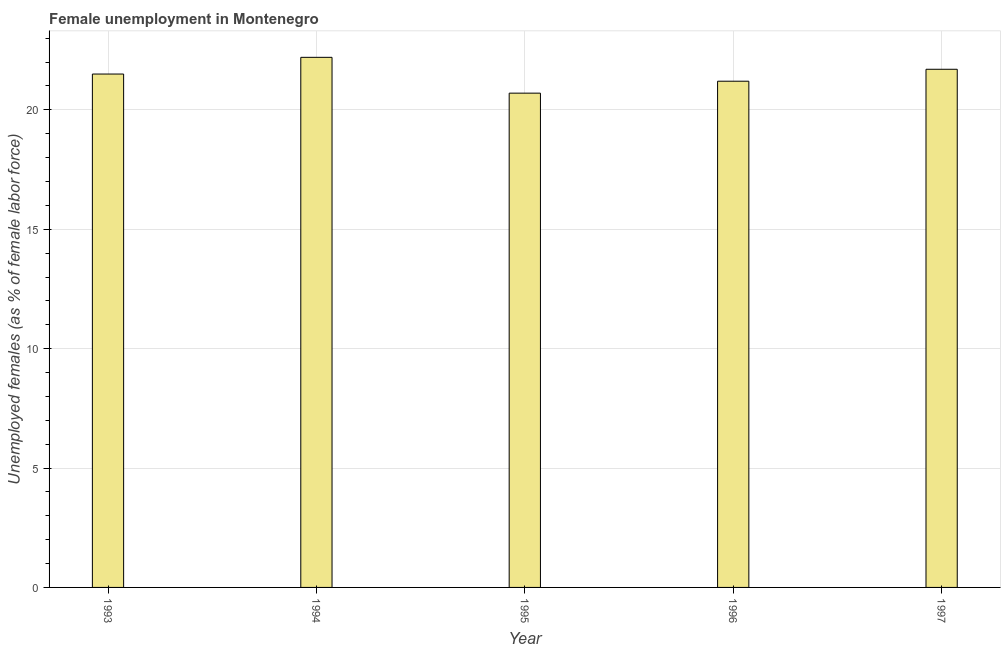Does the graph contain any zero values?
Keep it short and to the point. No. What is the title of the graph?
Provide a short and direct response. Female unemployment in Montenegro. What is the label or title of the Y-axis?
Ensure brevity in your answer.  Unemployed females (as % of female labor force). Across all years, what is the maximum unemployed females population?
Give a very brief answer. 22.2. Across all years, what is the minimum unemployed females population?
Ensure brevity in your answer.  20.7. In which year was the unemployed females population maximum?
Your answer should be very brief. 1994. In which year was the unemployed females population minimum?
Your answer should be very brief. 1995. What is the sum of the unemployed females population?
Make the answer very short. 107.3. What is the difference between the unemployed females population in 1993 and 1994?
Offer a very short reply. -0.7. What is the average unemployed females population per year?
Your answer should be compact. 21.46. In how many years, is the unemployed females population greater than 12 %?
Ensure brevity in your answer.  5. Do a majority of the years between 1994 and 1997 (inclusive) have unemployed females population greater than 1 %?
Provide a succinct answer. Yes. Is the sum of the unemployed females population in 1994 and 1997 greater than the maximum unemployed females population across all years?
Your answer should be compact. Yes. What is the difference between the highest and the lowest unemployed females population?
Ensure brevity in your answer.  1.5. In how many years, is the unemployed females population greater than the average unemployed females population taken over all years?
Make the answer very short. 3. How many bars are there?
Your response must be concise. 5. Are all the bars in the graph horizontal?
Your answer should be compact. No. How many years are there in the graph?
Provide a short and direct response. 5. What is the difference between two consecutive major ticks on the Y-axis?
Provide a short and direct response. 5. Are the values on the major ticks of Y-axis written in scientific E-notation?
Provide a short and direct response. No. What is the Unemployed females (as % of female labor force) in 1994?
Keep it short and to the point. 22.2. What is the Unemployed females (as % of female labor force) of 1995?
Offer a very short reply. 20.7. What is the Unemployed females (as % of female labor force) of 1996?
Your answer should be compact. 21.2. What is the Unemployed females (as % of female labor force) in 1997?
Offer a terse response. 21.7. What is the difference between the Unemployed females (as % of female labor force) in 1993 and 1997?
Give a very brief answer. -0.2. What is the difference between the Unemployed females (as % of female labor force) in 1994 and 1995?
Provide a short and direct response. 1.5. What is the difference between the Unemployed females (as % of female labor force) in 1996 and 1997?
Ensure brevity in your answer.  -0.5. What is the ratio of the Unemployed females (as % of female labor force) in 1993 to that in 1994?
Offer a terse response. 0.97. What is the ratio of the Unemployed females (as % of female labor force) in 1993 to that in 1995?
Your response must be concise. 1.04. What is the ratio of the Unemployed females (as % of female labor force) in 1993 to that in 1996?
Offer a very short reply. 1.01. What is the ratio of the Unemployed females (as % of female labor force) in 1993 to that in 1997?
Your answer should be very brief. 0.99. What is the ratio of the Unemployed females (as % of female labor force) in 1994 to that in 1995?
Keep it short and to the point. 1.07. What is the ratio of the Unemployed females (as % of female labor force) in 1994 to that in 1996?
Offer a terse response. 1.05. What is the ratio of the Unemployed females (as % of female labor force) in 1995 to that in 1996?
Your response must be concise. 0.98. What is the ratio of the Unemployed females (as % of female labor force) in 1995 to that in 1997?
Your answer should be very brief. 0.95. What is the ratio of the Unemployed females (as % of female labor force) in 1996 to that in 1997?
Make the answer very short. 0.98. 